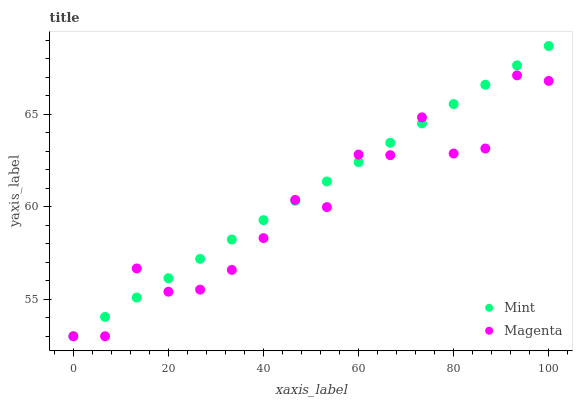Does Magenta have the minimum area under the curve?
Answer yes or no. Yes. Does Mint have the maximum area under the curve?
Answer yes or no. Yes. Does Mint have the minimum area under the curve?
Answer yes or no. No. Is Mint the smoothest?
Answer yes or no. Yes. Is Magenta the roughest?
Answer yes or no. Yes. Is Mint the roughest?
Answer yes or no. No. Does Magenta have the lowest value?
Answer yes or no. Yes. Does Mint have the highest value?
Answer yes or no. Yes. Does Mint intersect Magenta?
Answer yes or no. Yes. Is Mint less than Magenta?
Answer yes or no. No. Is Mint greater than Magenta?
Answer yes or no. No. 